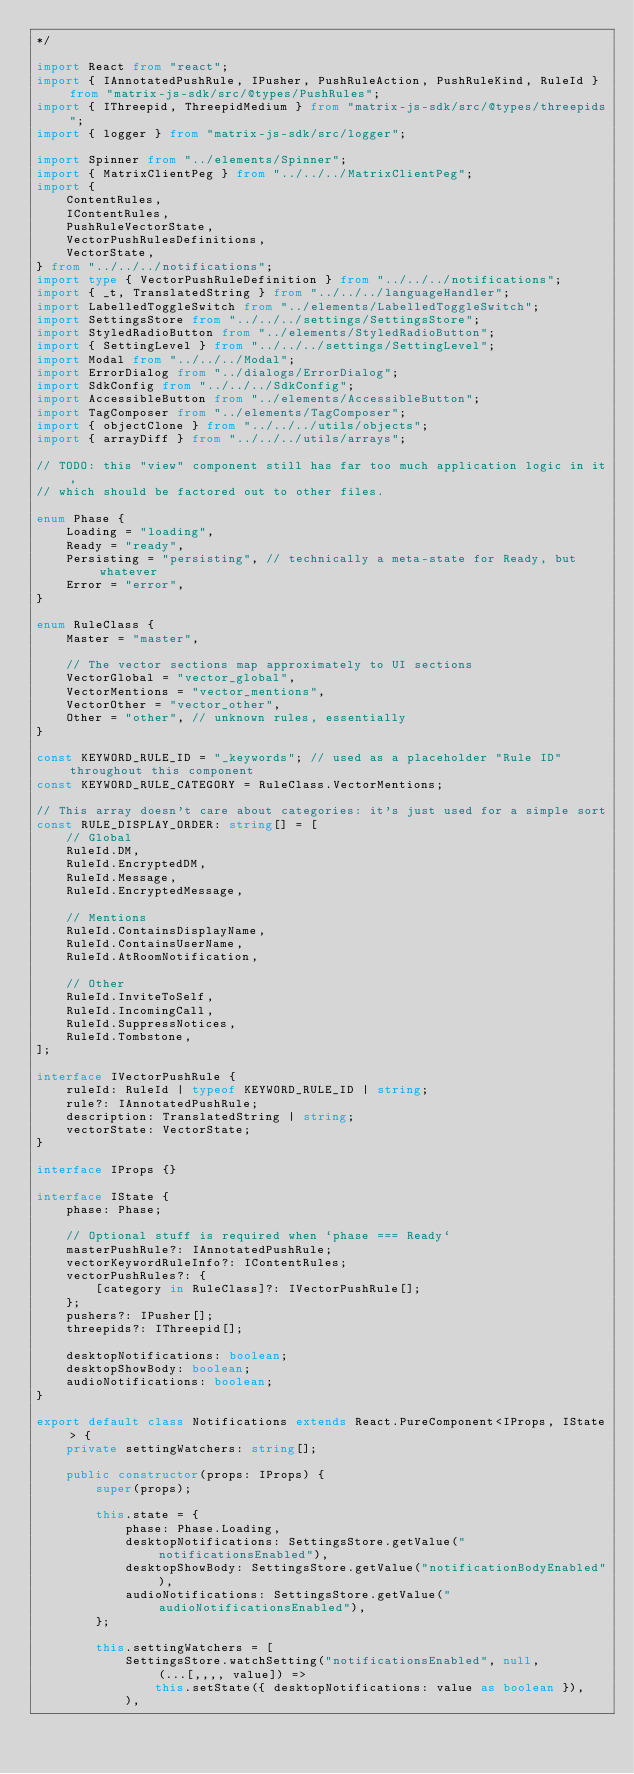<code> <loc_0><loc_0><loc_500><loc_500><_TypeScript_>*/

import React from "react";
import { IAnnotatedPushRule, IPusher, PushRuleAction, PushRuleKind, RuleId } from "matrix-js-sdk/src/@types/PushRules";
import { IThreepid, ThreepidMedium } from "matrix-js-sdk/src/@types/threepids";
import { logger } from "matrix-js-sdk/src/logger";

import Spinner from "../elements/Spinner";
import { MatrixClientPeg } from "../../../MatrixClientPeg";
import {
    ContentRules,
    IContentRules,
    PushRuleVectorState,
    VectorPushRulesDefinitions,
    VectorState,
} from "../../../notifications";
import type { VectorPushRuleDefinition } from "../../../notifications";
import { _t, TranslatedString } from "../../../languageHandler";
import LabelledToggleSwitch from "../elements/LabelledToggleSwitch";
import SettingsStore from "../../../settings/SettingsStore";
import StyledRadioButton from "../elements/StyledRadioButton";
import { SettingLevel } from "../../../settings/SettingLevel";
import Modal from "../../../Modal";
import ErrorDialog from "../dialogs/ErrorDialog";
import SdkConfig from "../../../SdkConfig";
import AccessibleButton from "../elements/AccessibleButton";
import TagComposer from "../elements/TagComposer";
import { objectClone } from "../../../utils/objects";
import { arrayDiff } from "../../../utils/arrays";

// TODO: this "view" component still has far too much application logic in it,
// which should be factored out to other files.

enum Phase {
    Loading = "loading",
    Ready = "ready",
    Persisting = "persisting", // technically a meta-state for Ready, but whatever
    Error = "error",
}

enum RuleClass {
    Master = "master",

    // The vector sections map approximately to UI sections
    VectorGlobal = "vector_global",
    VectorMentions = "vector_mentions",
    VectorOther = "vector_other",
    Other = "other", // unknown rules, essentially
}

const KEYWORD_RULE_ID = "_keywords"; // used as a placeholder "Rule ID" throughout this component
const KEYWORD_RULE_CATEGORY = RuleClass.VectorMentions;

// This array doesn't care about categories: it's just used for a simple sort
const RULE_DISPLAY_ORDER: string[] = [
    // Global
    RuleId.DM,
    RuleId.EncryptedDM,
    RuleId.Message,
    RuleId.EncryptedMessage,

    // Mentions
    RuleId.ContainsDisplayName,
    RuleId.ContainsUserName,
    RuleId.AtRoomNotification,

    // Other
    RuleId.InviteToSelf,
    RuleId.IncomingCall,
    RuleId.SuppressNotices,
    RuleId.Tombstone,
];

interface IVectorPushRule {
    ruleId: RuleId | typeof KEYWORD_RULE_ID | string;
    rule?: IAnnotatedPushRule;
    description: TranslatedString | string;
    vectorState: VectorState;
}

interface IProps {}

interface IState {
    phase: Phase;

    // Optional stuff is required when `phase === Ready`
    masterPushRule?: IAnnotatedPushRule;
    vectorKeywordRuleInfo?: IContentRules;
    vectorPushRules?: {
        [category in RuleClass]?: IVectorPushRule[];
    };
    pushers?: IPusher[];
    threepids?: IThreepid[];

    desktopNotifications: boolean;
    desktopShowBody: boolean;
    audioNotifications: boolean;
}

export default class Notifications extends React.PureComponent<IProps, IState> {
    private settingWatchers: string[];

    public constructor(props: IProps) {
        super(props);

        this.state = {
            phase: Phase.Loading,
            desktopNotifications: SettingsStore.getValue("notificationsEnabled"),
            desktopShowBody: SettingsStore.getValue("notificationBodyEnabled"),
            audioNotifications: SettingsStore.getValue("audioNotificationsEnabled"),
        };

        this.settingWatchers = [
            SettingsStore.watchSetting("notificationsEnabled", null, (...[,,,, value]) =>
                this.setState({ desktopNotifications: value as boolean }),
            ),</code> 